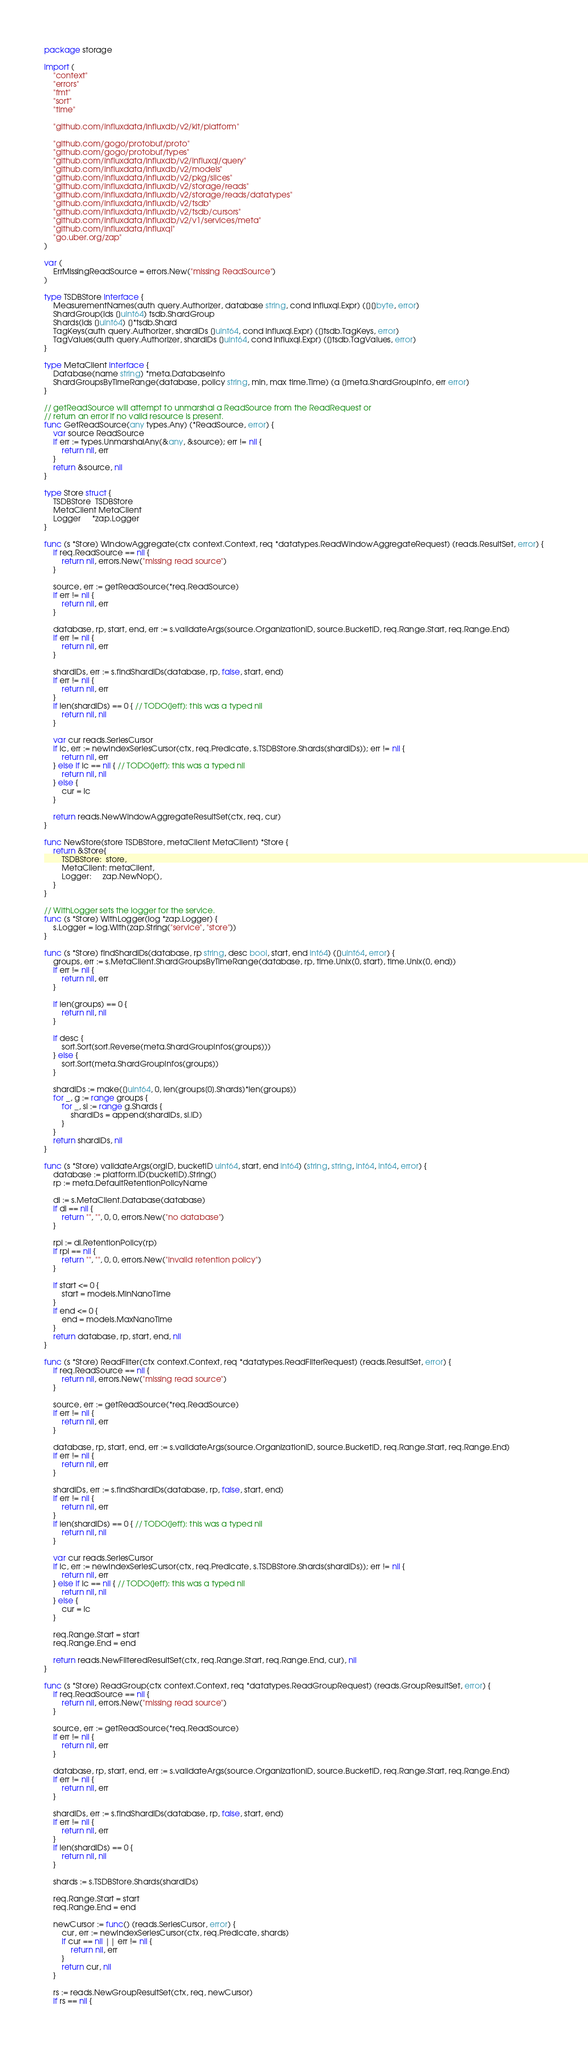<code> <loc_0><loc_0><loc_500><loc_500><_Go_>package storage

import (
	"context"
	"errors"
	"fmt"
	"sort"
	"time"

	"github.com/influxdata/influxdb/v2/kit/platform"

	"github.com/gogo/protobuf/proto"
	"github.com/gogo/protobuf/types"
	"github.com/influxdata/influxdb/v2/influxql/query"
	"github.com/influxdata/influxdb/v2/models"
	"github.com/influxdata/influxdb/v2/pkg/slices"
	"github.com/influxdata/influxdb/v2/storage/reads"
	"github.com/influxdata/influxdb/v2/storage/reads/datatypes"
	"github.com/influxdata/influxdb/v2/tsdb"
	"github.com/influxdata/influxdb/v2/tsdb/cursors"
	"github.com/influxdata/influxdb/v2/v1/services/meta"
	"github.com/influxdata/influxql"
	"go.uber.org/zap"
)

var (
	ErrMissingReadSource = errors.New("missing ReadSource")
)

type TSDBStore interface {
	MeasurementNames(auth query.Authorizer, database string, cond influxql.Expr) ([][]byte, error)
	ShardGroup(ids []uint64) tsdb.ShardGroup
	Shards(ids []uint64) []*tsdb.Shard
	TagKeys(auth query.Authorizer, shardIDs []uint64, cond influxql.Expr) ([]tsdb.TagKeys, error)
	TagValues(auth query.Authorizer, shardIDs []uint64, cond influxql.Expr) ([]tsdb.TagValues, error)
}

type MetaClient interface {
	Database(name string) *meta.DatabaseInfo
	ShardGroupsByTimeRange(database, policy string, min, max time.Time) (a []meta.ShardGroupInfo, err error)
}

// getReadSource will attempt to unmarshal a ReadSource from the ReadRequest or
// return an error if no valid resource is present.
func GetReadSource(any types.Any) (*ReadSource, error) {
	var source ReadSource
	if err := types.UnmarshalAny(&any, &source); err != nil {
		return nil, err
	}
	return &source, nil
}

type Store struct {
	TSDBStore  TSDBStore
	MetaClient MetaClient
	Logger     *zap.Logger
}

func (s *Store) WindowAggregate(ctx context.Context, req *datatypes.ReadWindowAggregateRequest) (reads.ResultSet, error) {
	if req.ReadSource == nil {
		return nil, errors.New("missing read source")
	}

	source, err := getReadSource(*req.ReadSource)
	if err != nil {
		return nil, err
	}

	database, rp, start, end, err := s.validateArgs(source.OrganizationID, source.BucketID, req.Range.Start, req.Range.End)
	if err != nil {
		return nil, err
	}

	shardIDs, err := s.findShardIDs(database, rp, false, start, end)
	if err != nil {
		return nil, err
	}
	if len(shardIDs) == 0 { // TODO(jeff): this was a typed nil
		return nil, nil
	}

	var cur reads.SeriesCursor
	if ic, err := newIndexSeriesCursor(ctx, req.Predicate, s.TSDBStore.Shards(shardIDs)); err != nil {
		return nil, err
	} else if ic == nil { // TODO(jeff): this was a typed nil
		return nil, nil
	} else {
		cur = ic
	}

	return reads.NewWindowAggregateResultSet(ctx, req, cur)
}

func NewStore(store TSDBStore, metaClient MetaClient) *Store {
	return &Store{
		TSDBStore:  store,
		MetaClient: metaClient,
		Logger:     zap.NewNop(),
	}
}

// WithLogger sets the logger for the service.
func (s *Store) WithLogger(log *zap.Logger) {
	s.Logger = log.With(zap.String("service", "store"))
}

func (s *Store) findShardIDs(database, rp string, desc bool, start, end int64) ([]uint64, error) {
	groups, err := s.MetaClient.ShardGroupsByTimeRange(database, rp, time.Unix(0, start), time.Unix(0, end))
	if err != nil {
		return nil, err
	}

	if len(groups) == 0 {
		return nil, nil
	}

	if desc {
		sort.Sort(sort.Reverse(meta.ShardGroupInfos(groups)))
	} else {
		sort.Sort(meta.ShardGroupInfos(groups))
	}

	shardIDs := make([]uint64, 0, len(groups[0].Shards)*len(groups))
	for _, g := range groups {
		for _, si := range g.Shards {
			shardIDs = append(shardIDs, si.ID)
		}
	}
	return shardIDs, nil
}

func (s *Store) validateArgs(orgID, bucketID uint64, start, end int64) (string, string, int64, int64, error) {
	database := platform.ID(bucketID).String()
	rp := meta.DefaultRetentionPolicyName

	di := s.MetaClient.Database(database)
	if di == nil {
		return "", "", 0, 0, errors.New("no database")
	}

	rpi := di.RetentionPolicy(rp)
	if rpi == nil {
		return "", "", 0, 0, errors.New("invalid retention policy")
	}

	if start <= 0 {
		start = models.MinNanoTime
	}
	if end <= 0 {
		end = models.MaxNanoTime
	}
	return database, rp, start, end, nil
}

func (s *Store) ReadFilter(ctx context.Context, req *datatypes.ReadFilterRequest) (reads.ResultSet, error) {
	if req.ReadSource == nil {
		return nil, errors.New("missing read source")
	}

	source, err := getReadSource(*req.ReadSource)
	if err != nil {
		return nil, err
	}

	database, rp, start, end, err := s.validateArgs(source.OrganizationID, source.BucketID, req.Range.Start, req.Range.End)
	if err != nil {
		return nil, err
	}

	shardIDs, err := s.findShardIDs(database, rp, false, start, end)
	if err != nil {
		return nil, err
	}
	if len(shardIDs) == 0 { // TODO(jeff): this was a typed nil
		return nil, nil
	}

	var cur reads.SeriesCursor
	if ic, err := newIndexSeriesCursor(ctx, req.Predicate, s.TSDBStore.Shards(shardIDs)); err != nil {
		return nil, err
	} else if ic == nil { // TODO(jeff): this was a typed nil
		return nil, nil
	} else {
		cur = ic
	}

	req.Range.Start = start
	req.Range.End = end

	return reads.NewFilteredResultSet(ctx, req.Range.Start, req.Range.End, cur), nil
}

func (s *Store) ReadGroup(ctx context.Context, req *datatypes.ReadGroupRequest) (reads.GroupResultSet, error) {
	if req.ReadSource == nil {
		return nil, errors.New("missing read source")
	}

	source, err := getReadSource(*req.ReadSource)
	if err != nil {
		return nil, err
	}

	database, rp, start, end, err := s.validateArgs(source.OrganizationID, source.BucketID, req.Range.Start, req.Range.End)
	if err != nil {
		return nil, err
	}

	shardIDs, err := s.findShardIDs(database, rp, false, start, end)
	if err != nil {
		return nil, err
	}
	if len(shardIDs) == 0 {
		return nil, nil
	}

	shards := s.TSDBStore.Shards(shardIDs)

	req.Range.Start = start
	req.Range.End = end

	newCursor := func() (reads.SeriesCursor, error) {
		cur, err := newIndexSeriesCursor(ctx, req.Predicate, shards)
		if cur == nil || err != nil {
			return nil, err
		}
		return cur, nil
	}

	rs := reads.NewGroupResultSet(ctx, req, newCursor)
	if rs == nil {</code> 